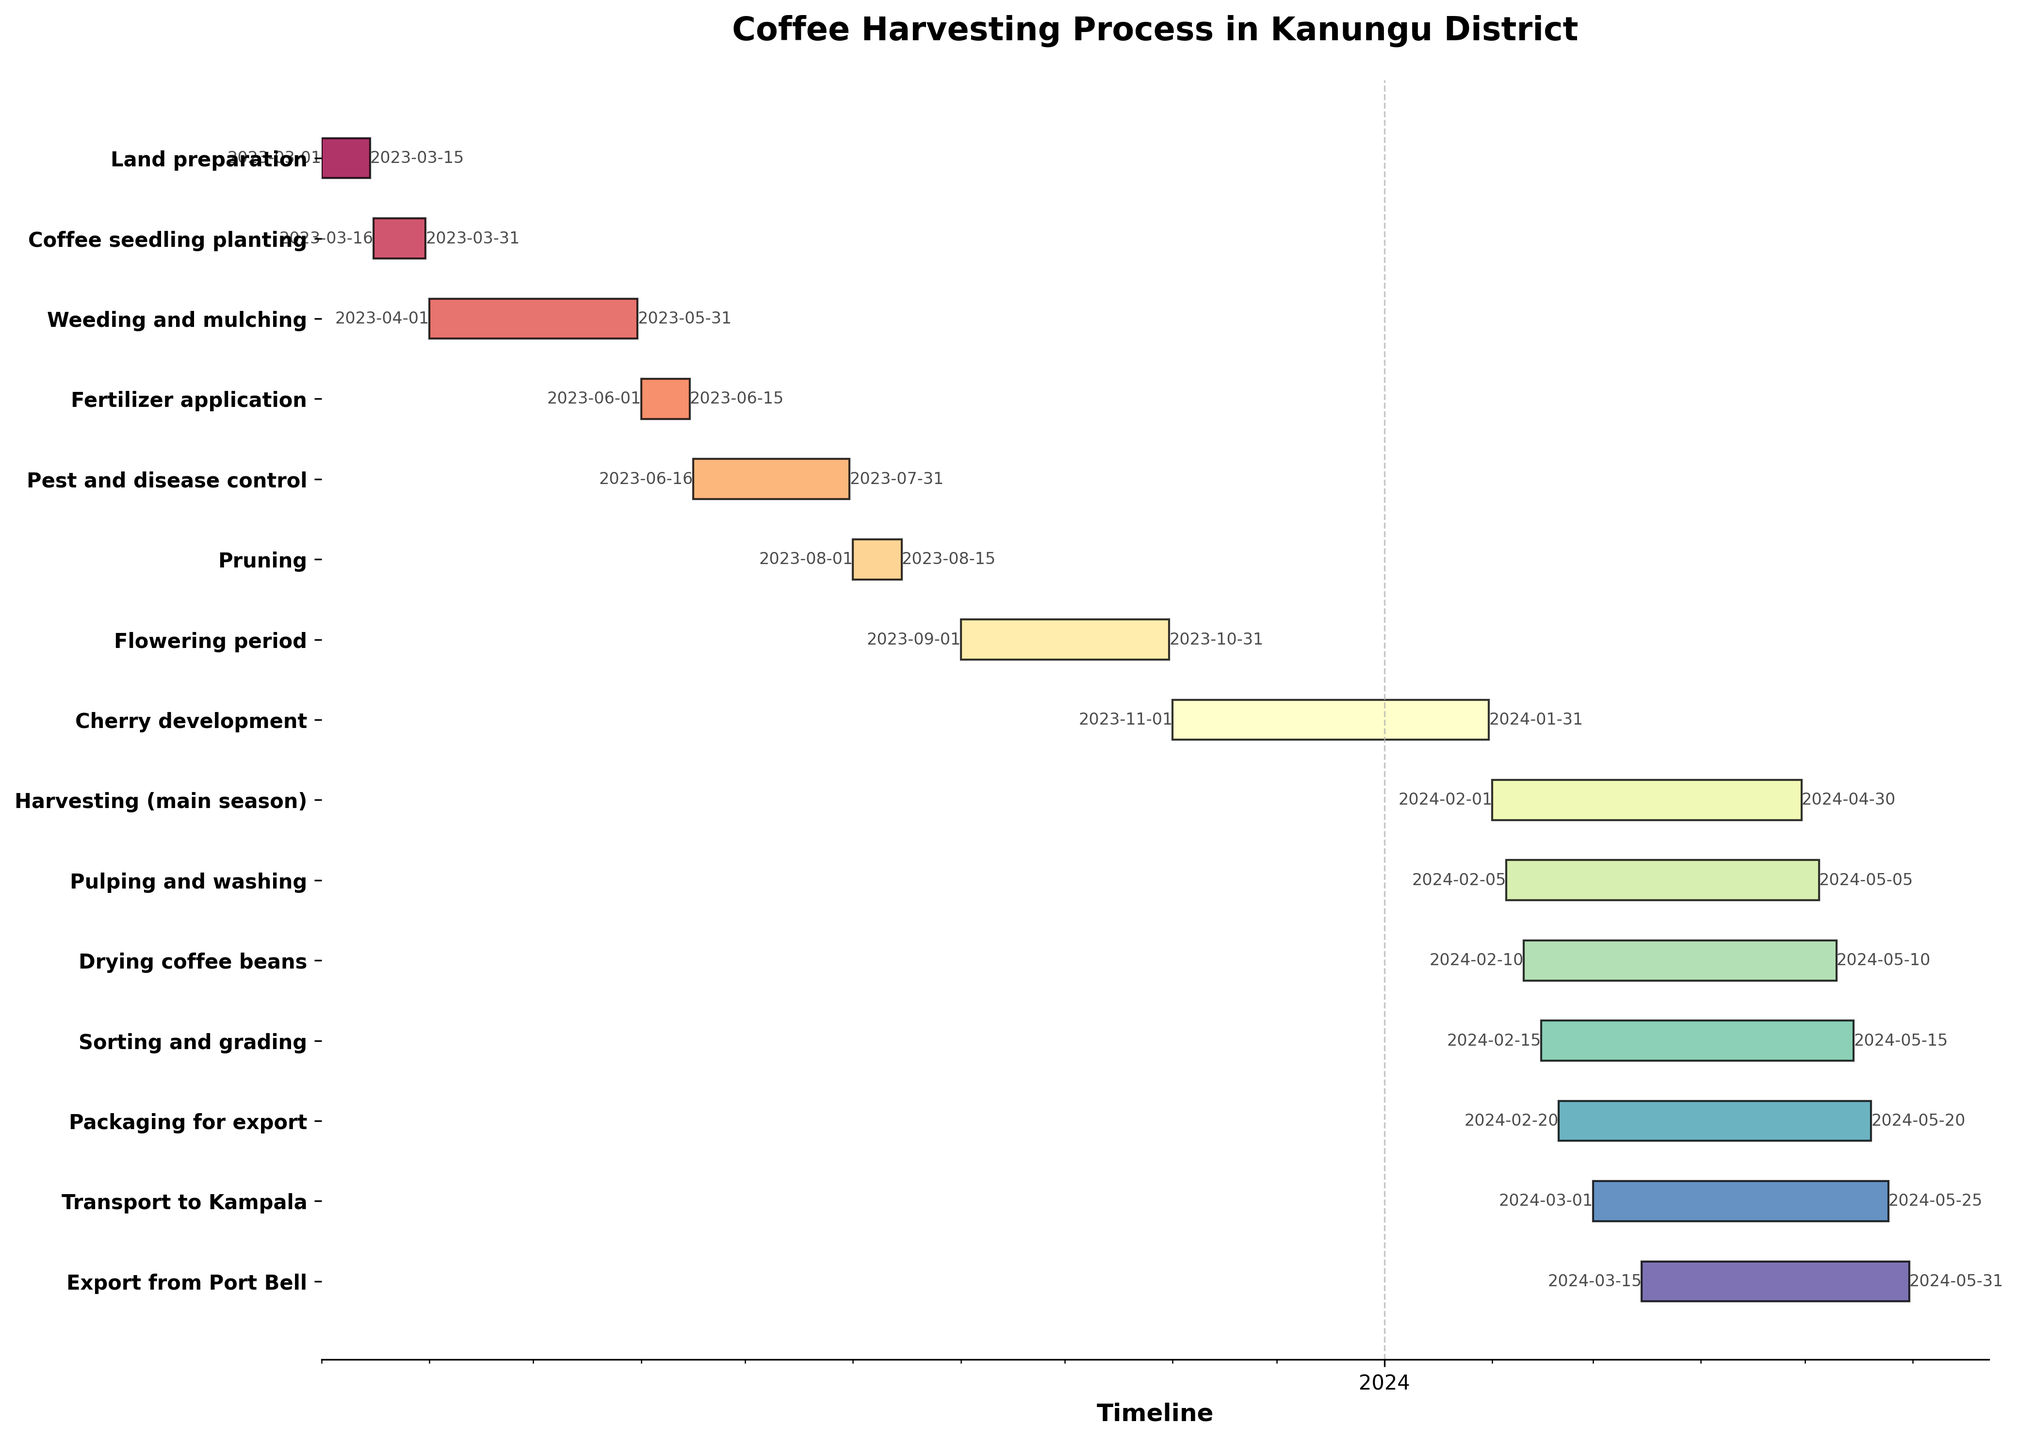What's the title of the Gantt chart? The title of the Gantt chart is prominent at the top and reads 'Coffee Harvesting Process in Kanungu District'.
Answer: Coffee Harvesting Process in Kanungu District When does the 'Land preparation' task start and end? This task starts on 2023-03-01 and ends on 2023-03-15 as indicated on the horizontal bars at the top of the chart.
Answer: 2023-03-01 to 2023-03-15 How many months does the 'Weeding and mulching' task span? This task starts on 2023-04-01 and ends on 2023-05-31. To find the duration in months, count from April to May inclusive.
Answer: 2 months Which task has the longest duration, and what are its start and end dates? The task with the longest horizontal bar is 'Cherry development', which starts on 2023-11-01 and ends on 2024-01-31.
Answer: Cherry development, 2023-11-01 to 2024-01-31 How many tasks overlap at least partially in February 2024? To find this, locate February 2024 on the timeline and check tasks that have bars extending into this month: 'Harvesting (main season)', 'Pulping and washing', 'Drying coffee beans', 'Sorting and grading', 'Packaging for export'.
Answer: 5 tasks Which two tasks have exactly the same duration? Comparing the length of the bars, 'Pulping and washing' and 'Drying coffee beans' both start in early February 2024 and end in early May 2024, each lasting approximately 91 days.
Answer: Pulping and washing, Drying coffee beans What comes directly after 'Coffee seedling planting'? Right after the 'Coffee seedling planting' (ending on 2023-03-31), the 'Weeding and mulching' task starts on 2023-04-01.
Answer: Weeding and mulching Is there any task that starts and finishes within the same month, and if so, which one? The 'Pruning' task starts on 2023-08-01 and ends on 2023-08-15, all within August 2023.
Answer: Pruning 